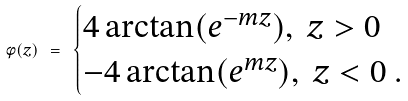Convert formula to latex. <formula><loc_0><loc_0><loc_500><loc_500>\phi ( z ) \ = \ \begin{cases} 4 \arctan ( e ^ { - m z } ) , \ z > 0 \\ - 4 \arctan ( e ^ { m z } ) , \ z < 0 \ . \end{cases}</formula> 